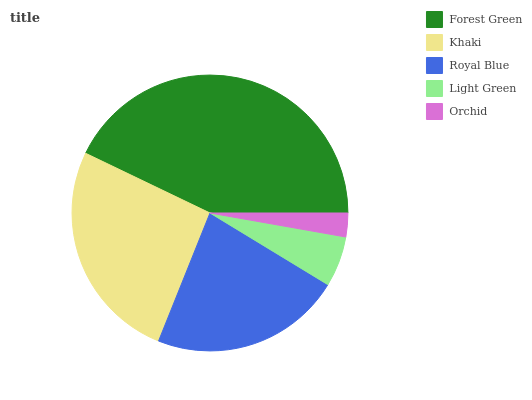Is Orchid the minimum?
Answer yes or no. Yes. Is Forest Green the maximum?
Answer yes or no. Yes. Is Khaki the minimum?
Answer yes or no. No. Is Khaki the maximum?
Answer yes or no. No. Is Forest Green greater than Khaki?
Answer yes or no. Yes. Is Khaki less than Forest Green?
Answer yes or no. Yes. Is Khaki greater than Forest Green?
Answer yes or no. No. Is Forest Green less than Khaki?
Answer yes or no. No. Is Royal Blue the high median?
Answer yes or no. Yes. Is Royal Blue the low median?
Answer yes or no. Yes. Is Light Green the high median?
Answer yes or no. No. Is Khaki the low median?
Answer yes or no. No. 